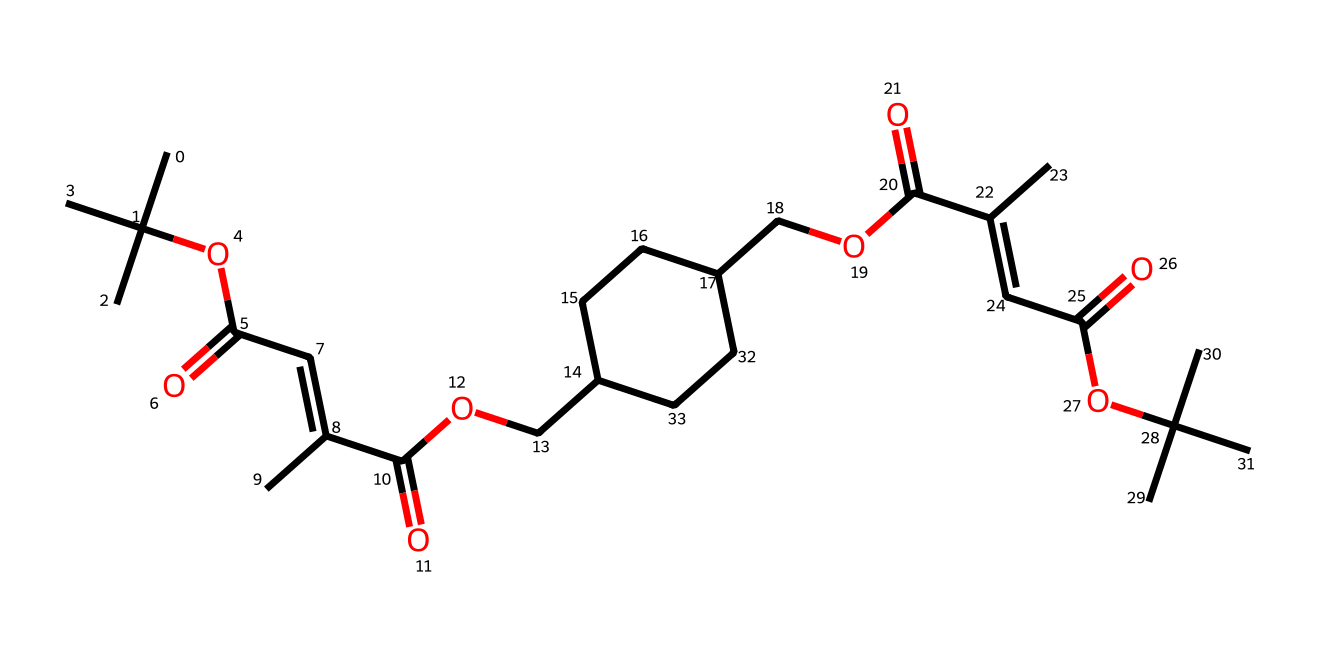What is the total number of carbon atoms in this chemical structure? By analyzing the SMILES representation, we can count the number of 'C' characters, which represent carbon atoms. In this specific structure, there are 25 carbon atoms.
Answer: 25 How many ester functional groups are present in this molecule? In the chemical structure, ester functional groups are identified as -OC(=O)-. By examining the SMILES, we can find 3 instances of this group.
Answer: 3 What type of reaction is facilitated by this biodegradable photoresist? The structure includes multiple functional groups that indicate it can undergo photopolymerization, a common reaction for photoresists which allows for patterning in electronics manufacturing.
Answer: photopolymerization How many double bonds are present in this chemical structure? By reviewing the SMILES representation, we can identify the double bonds indicated by '='. In this case, there are 3 double bonds in total.
Answer: 3 Is this photoresist likely to be soluble in water? Analyzing the presence of polar functional groups such as -COOH and -O- in the structure suggests it has the potential to have some water solubility, but since the structure also contains large hydrophobic groups, it will likely have limited solubility.
Answer: limited What is the role of the alkene groups in this chemical? The alkene groups (C=C) in the structure are crucial for the reactivity of the photoresist during the exposure process to light, enabling the formation of cross-links that stabilize the patterns made during manufacturing.
Answer: reactivity 